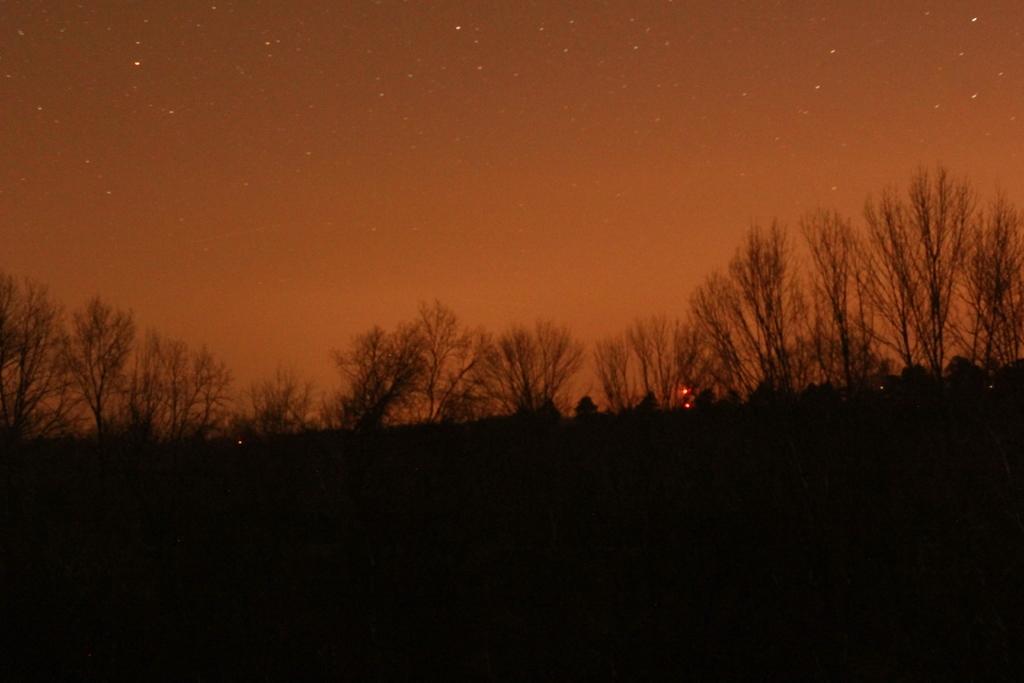Could you give a brief overview of what you see in this image? In this image there are plants and trees. At the top there is the sky. At the bottom it is dark. 